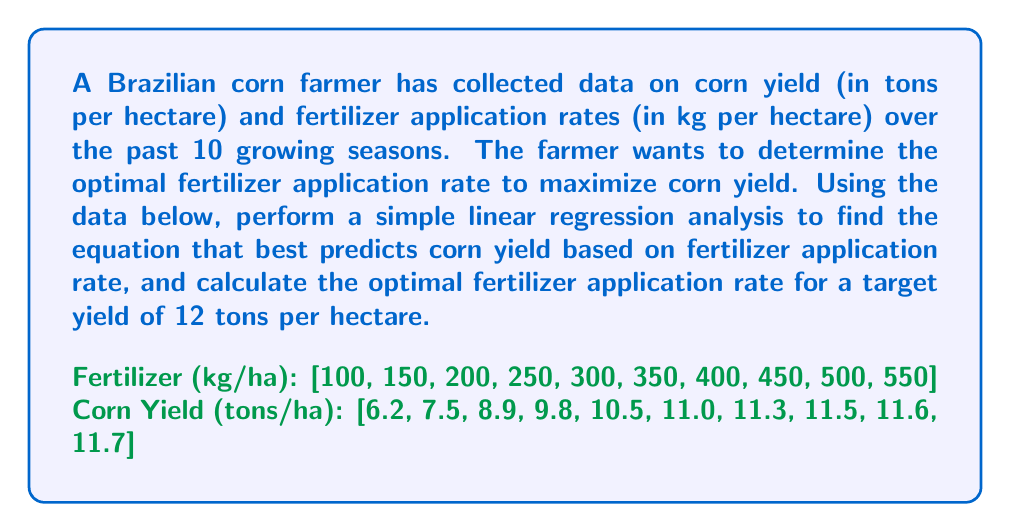Can you solve this math problem? To solve this problem, we'll follow these steps:

1. Perform simple linear regression
2. Interpret the results
3. Calculate the optimal fertilizer application rate

Step 1: Perform simple linear regression

Let $x$ be the fertilizer application rate and $y$ be the corn yield. We'll use the following formulas:

$$\bar{x} = \frac{\sum x_i}{n}, \quad \bar{y} = \frac{\sum y_i}{n}$$
$$m = \frac{\sum (x_i - \bar{x})(y_i - \bar{y})}{\sum (x_i - \bar{x})^2}$$
$$b = \bar{y} - m\bar{x}$$

Calculating the means:
$$\bar{x} = 325, \quad \bar{y} = 10$$

Calculating the slope (m):
$$m = \frac{13275}{472500} = 0.0281$$

Calculating the y-intercept (b):
$$b = 10 - 0.0281 \times 325 = 0.8675$$

The regression equation is:
$$y = 0.0281x + 0.8675$$

Step 2: Interpret the results

The equation suggests that for every 1 kg/ha increase in fertilizer, the corn yield increases by 0.0281 tons/ha.

Step 3: Calculate the optimal fertilizer application rate

To find the optimal fertilizer rate for a target yield of 12 tons/ha, we solve the equation:

$$12 = 0.0281x + 0.8675$$
$$11.1325 = 0.0281x$$
$$x = 396.17$$

Therefore, the optimal fertilizer application rate for a target yield of 12 tons/ha is approximately 396.17 kg/ha.
Answer: The optimal fertilizer application rate for a target corn yield of 12 tons per hectare is approximately 396.17 kg per hectare. 